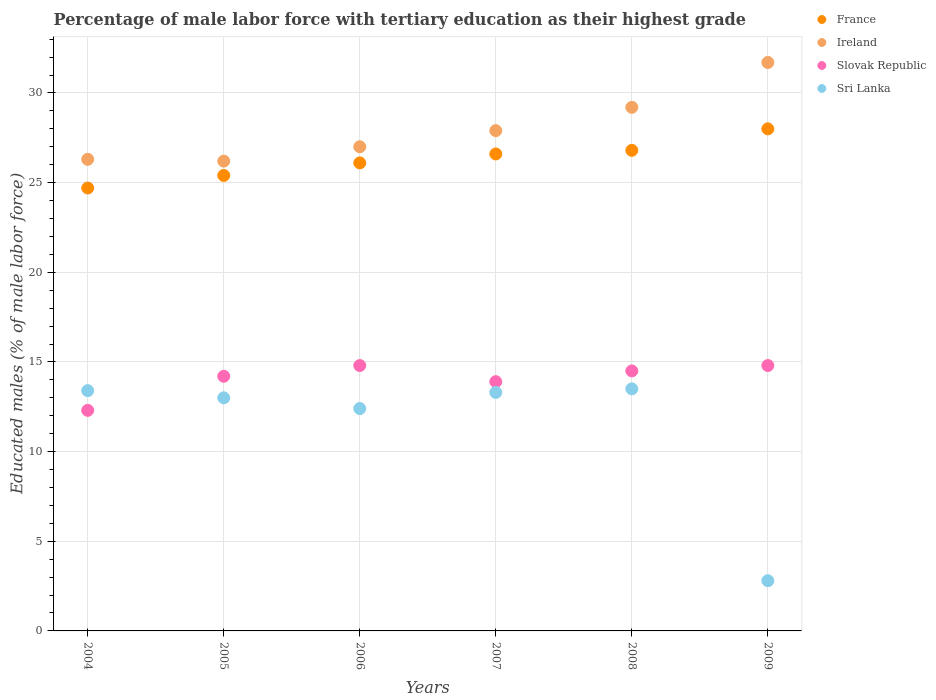What is the percentage of male labor force with tertiary education in Ireland in 2009?
Provide a short and direct response. 31.7. Across all years, what is the maximum percentage of male labor force with tertiary education in Sri Lanka?
Ensure brevity in your answer.  13.5. Across all years, what is the minimum percentage of male labor force with tertiary education in Slovak Republic?
Offer a terse response. 12.3. What is the total percentage of male labor force with tertiary education in France in the graph?
Ensure brevity in your answer.  157.6. What is the difference between the percentage of male labor force with tertiary education in Sri Lanka in 2005 and that in 2009?
Keep it short and to the point. 10.2. What is the difference between the percentage of male labor force with tertiary education in Ireland in 2009 and the percentage of male labor force with tertiary education in Slovak Republic in 2008?
Make the answer very short. 17.2. What is the average percentage of male labor force with tertiary education in Ireland per year?
Keep it short and to the point. 28.05. In the year 2009, what is the difference between the percentage of male labor force with tertiary education in France and percentage of male labor force with tertiary education in Ireland?
Your answer should be compact. -3.7. In how many years, is the percentage of male labor force with tertiary education in France greater than 32 %?
Provide a succinct answer. 0. What is the ratio of the percentage of male labor force with tertiary education in Sri Lanka in 2007 to that in 2009?
Your answer should be compact. 4.75. Is the percentage of male labor force with tertiary education in France in 2006 less than that in 2008?
Provide a short and direct response. Yes. Is the difference between the percentage of male labor force with tertiary education in France in 2006 and 2009 greater than the difference between the percentage of male labor force with tertiary education in Ireland in 2006 and 2009?
Your answer should be very brief. Yes. What is the difference between the highest and the second highest percentage of male labor force with tertiary education in Sri Lanka?
Your answer should be compact. 0.1. What is the difference between the highest and the lowest percentage of male labor force with tertiary education in France?
Make the answer very short. 3.3. Is the sum of the percentage of male labor force with tertiary education in Sri Lanka in 2004 and 2009 greater than the maximum percentage of male labor force with tertiary education in France across all years?
Your answer should be compact. No. Is it the case that in every year, the sum of the percentage of male labor force with tertiary education in Slovak Republic and percentage of male labor force with tertiary education in Sri Lanka  is greater than the sum of percentage of male labor force with tertiary education in Ireland and percentage of male labor force with tertiary education in France?
Your answer should be very brief. No. Is it the case that in every year, the sum of the percentage of male labor force with tertiary education in Ireland and percentage of male labor force with tertiary education in Sri Lanka  is greater than the percentage of male labor force with tertiary education in France?
Your answer should be very brief. Yes. Does the percentage of male labor force with tertiary education in Slovak Republic monotonically increase over the years?
Give a very brief answer. No. Is the percentage of male labor force with tertiary education in Sri Lanka strictly less than the percentage of male labor force with tertiary education in Ireland over the years?
Provide a succinct answer. Yes. How many dotlines are there?
Provide a succinct answer. 4. How many years are there in the graph?
Keep it short and to the point. 6. What is the difference between two consecutive major ticks on the Y-axis?
Ensure brevity in your answer.  5. Are the values on the major ticks of Y-axis written in scientific E-notation?
Your answer should be very brief. No. Does the graph contain any zero values?
Your response must be concise. No. What is the title of the graph?
Offer a very short reply. Percentage of male labor force with tertiary education as their highest grade. Does "Macedonia" appear as one of the legend labels in the graph?
Give a very brief answer. No. What is the label or title of the Y-axis?
Keep it short and to the point. Educated males (% of male labor force). What is the Educated males (% of male labor force) of France in 2004?
Make the answer very short. 24.7. What is the Educated males (% of male labor force) in Ireland in 2004?
Keep it short and to the point. 26.3. What is the Educated males (% of male labor force) in Slovak Republic in 2004?
Provide a short and direct response. 12.3. What is the Educated males (% of male labor force) of Sri Lanka in 2004?
Your answer should be compact. 13.4. What is the Educated males (% of male labor force) in France in 2005?
Make the answer very short. 25.4. What is the Educated males (% of male labor force) in Ireland in 2005?
Offer a terse response. 26.2. What is the Educated males (% of male labor force) in Slovak Republic in 2005?
Give a very brief answer. 14.2. What is the Educated males (% of male labor force) of France in 2006?
Ensure brevity in your answer.  26.1. What is the Educated males (% of male labor force) in Slovak Republic in 2006?
Give a very brief answer. 14.8. What is the Educated males (% of male labor force) of Sri Lanka in 2006?
Provide a succinct answer. 12.4. What is the Educated males (% of male labor force) of France in 2007?
Your response must be concise. 26.6. What is the Educated males (% of male labor force) of Ireland in 2007?
Your answer should be very brief. 27.9. What is the Educated males (% of male labor force) of Slovak Republic in 2007?
Provide a succinct answer. 13.9. What is the Educated males (% of male labor force) in Sri Lanka in 2007?
Give a very brief answer. 13.3. What is the Educated males (% of male labor force) in France in 2008?
Provide a short and direct response. 26.8. What is the Educated males (% of male labor force) in Ireland in 2008?
Offer a very short reply. 29.2. What is the Educated males (% of male labor force) in France in 2009?
Your response must be concise. 28. What is the Educated males (% of male labor force) of Ireland in 2009?
Provide a short and direct response. 31.7. What is the Educated males (% of male labor force) in Slovak Republic in 2009?
Offer a very short reply. 14.8. What is the Educated males (% of male labor force) of Sri Lanka in 2009?
Make the answer very short. 2.8. Across all years, what is the maximum Educated males (% of male labor force) of Ireland?
Make the answer very short. 31.7. Across all years, what is the maximum Educated males (% of male labor force) in Slovak Republic?
Offer a terse response. 14.8. Across all years, what is the maximum Educated males (% of male labor force) in Sri Lanka?
Ensure brevity in your answer.  13.5. Across all years, what is the minimum Educated males (% of male labor force) in France?
Your answer should be compact. 24.7. Across all years, what is the minimum Educated males (% of male labor force) in Ireland?
Provide a short and direct response. 26.2. Across all years, what is the minimum Educated males (% of male labor force) of Slovak Republic?
Your answer should be very brief. 12.3. Across all years, what is the minimum Educated males (% of male labor force) of Sri Lanka?
Offer a terse response. 2.8. What is the total Educated males (% of male labor force) in France in the graph?
Provide a short and direct response. 157.6. What is the total Educated males (% of male labor force) of Ireland in the graph?
Your answer should be very brief. 168.3. What is the total Educated males (% of male labor force) in Slovak Republic in the graph?
Offer a terse response. 84.5. What is the total Educated males (% of male labor force) of Sri Lanka in the graph?
Your answer should be compact. 68.4. What is the difference between the Educated males (% of male labor force) of Ireland in 2004 and that in 2005?
Provide a short and direct response. 0.1. What is the difference between the Educated males (% of male labor force) of Sri Lanka in 2004 and that in 2005?
Offer a terse response. 0.4. What is the difference between the Educated males (% of male labor force) in Slovak Republic in 2004 and that in 2006?
Make the answer very short. -2.5. What is the difference between the Educated males (% of male labor force) of Sri Lanka in 2004 and that in 2006?
Provide a short and direct response. 1. What is the difference between the Educated males (% of male labor force) in Slovak Republic in 2004 and that in 2007?
Your response must be concise. -1.6. What is the difference between the Educated males (% of male labor force) of Sri Lanka in 2004 and that in 2007?
Make the answer very short. 0.1. What is the difference between the Educated males (% of male labor force) of Slovak Republic in 2004 and that in 2008?
Offer a very short reply. -2.2. What is the difference between the Educated males (% of male labor force) of Slovak Republic in 2004 and that in 2009?
Offer a very short reply. -2.5. What is the difference between the Educated males (% of male labor force) in Sri Lanka in 2004 and that in 2009?
Your answer should be compact. 10.6. What is the difference between the Educated males (% of male labor force) of Sri Lanka in 2005 and that in 2006?
Make the answer very short. 0.6. What is the difference between the Educated males (% of male labor force) in France in 2005 and that in 2007?
Offer a very short reply. -1.2. What is the difference between the Educated males (% of male labor force) of Ireland in 2005 and that in 2007?
Your answer should be very brief. -1.7. What is the difference between the Educated males (% of male labor force) in Slovak Republic in 2005 and that in 2007?
Give a very brief answer. 0.3. What is the difference between the Educated males (% of male labor force) in Sri Lanka in 2005 and that in 2007?
Make the answer very short. -0.3. What is the difference between the Educated males (% of male labor force) of France in 2005 and that in 2008?
Offer a very short reply. -1.4. What is the difference between the Educated males (% of male labor force) of Slovak Republic in 2005 and that in 2008?
Give a very brief answer. -0.3. What is the difference between the Educated males (% of male labor force) of France in 2005 and that in 2009?
Provide a succinct answer. -2.6. What is the difference between the Educated males (% of male labor force) of Ireland in 2005 and that in 2009?
Your answer should be very brief. -5.5. What is the difference between the Educated males (% of male labor force) in Slovak Republic in 2006 and that in 2007?
Your answer should be compact. 0.9. What is the difference between the Educated males (% of male labor force) of Sri Lanka in 2006 and that in 2007?
Give a very brief answer. -0.9. What is the difference between the Educated males (% of male labor force) in France in 2006 and that in 2008?
Keep it short and to the point. -0.7. What is the difference between the Educated males (% of male labor force) of Ireland in 2006 and that in 2009?
Offer a terse response. -4.7. What is the difference between the Educated males (% of male labor force) in Sri Lanka in 2006 and that in 2009?
Offer a terse response. 9.6. What is the difference between the Educated males (% of male labor force) in Ireland in 2007 and that in 2008?
Give a very brief answer. -1.3. What is the difference between the Educated males (% of male labor force) of Sri Lanka in 2007 and that in 2008?
Provide a succinct answer. -0.2. What is the difference between the Educated males (% of male labor force) in France in 2007 and that in 2009?
Offer a very short reply. -1.4. What is the difference between the Educated males (% of male labor force) of Ireland in 2008 and that in 2009?
Keep it short and to the point. -2.5. What is the difference between the Educated males (% of male labor force) in Slovak Republic in 2008 and that in 2009?
Give a very brief answer. -0.3. What is the difference between the Educated males (% of male labor force) in Sri Lanka in 2008 and that in 2009?
Keep it short and to the point. 10.7. What is the difference between the Educated males (% of male labor force) in France in 2004 and the Educated males (% of male labor force) in Slovak Republic in 2005?
Provide a succinct answer. 10.5. What is the difference between the Educated males (% of male labor force) of France in 2004 and the Educated males (% of male labor force) of Sri Lanka in 2005?
Your response must be concise. 11.7. What is the difference between the Educated males (% of male labor force) of Ireland in 2004 and the Educated males (% of male labor force) of Slovak Republic in 2005?
Provide a succinct answer. 12.1. What is the difference between the Educated males (% of male labor force) of Ireland in 2004 and the Educated males (% of male labor force) of Sri Lanka in 2005?
Provide a succinct answer. 13.3. What is the difference between the Educated males (% of male labor force) in France in 2004 and the Educated males (% of male labor force) in Ireland in 2006?
Your response must be concise. -2.3. What is the difference between the Educated males (% of male labor force) of Ireland in 2004 and the Educated males (% of male labor force) of Slovak Republic in 2006?
Give a very brief answer. 11.5. What is the difference between the Educated males (% of male labor force) in Slovak Republic in 2004 and the Educated males (% of male labor force) in Sri Lanka in 2006?
Provide a succinct answer. -0.1. What is the difference between the Educated males (% of male labor force) in France in 2004 and the Educated males (% of male labor force) in Ireland in 2007?
Offer a terse response. -3.2. What is the difference between the Educated males (% of male labor force) of France in 2004 and the Educated males (% of male labor force) of Slovak Republic in 2007?
Make the answer very short. 10.8. What is the difference between the Educated males (% of male labor force) of Slovak Republic in 2004 and the Educated males (% of male labor force) of Sri Lanka in 2007?
Ensure brevity in your answer.  -1. What is the difference between the Educated males (% of male labor force) of France in 2004 and the Educated males (% of male labor force) of Ireland in 2008?
Give a very brief answer. -4.5. What is the difference between the Educated males (% of male labor force) in France in 2004 and the Educated males (% of male labor force) in Sri Lanka in 2008?
Provide a short and direct response. 11.2. What is the difference between the Educated males (% of male labor force) of Ireland in 2004 and the Educated males (% of male labor force) of Sri Lanka in 2008?
Provide a short and direct response. 12.8. What is the difference between the Educated males (% of male labor force) of Slovak Republic in 2004 and the Educated males (% of male labor force) of Sri Lanka in 2008?
Your response must be concise. -1.2. What is the difference between the Educated males (% of male labor force) of France in 2004 and the Educated males (% of male labor force) of Ireland in 2009?
Your response must be concise. -7. What is the difference between the Educated males (% of male labor force) in France in 2004 and the Educated males (% of male labor force) in Sri Lanka in 2009?
Offer a very short reply. 21.9. What is the difference between the Educated males (% of male labor force) in Slovak Republic in 2004 and the Educated males (% of male labor force) in Sri Lanka in 2009?
Offer a very short reply. 9.5. What is the difference between the Educated males (% of male labor force) of France in 2005 and the Educated males (% of male labor force) of Ireland in 2006?
Offer a terse response. -1.6. What is the difference between the Educated males (% of male labor force) of Ireland in 2005 and the Educated males (% of male labor force) of Sri Lanka in 2006?
Provide a succinct answer. 13.8. What is the difference between the Educated males (% of male labor force) in France in 2005 and the Educated males (% of male labor force) in Slovak Republic in 2007?
Make the answer very short. 11.5. What is the difference between the Educated males (% of male labor force) of France in 2005 and the Educated males (% of male labor force) of Sri Lanka in 2007?
Your answer should be compact. 12.1. What is the difference between the Educated males (% of male labor force) in Ireland in 2005 and the Educated males (% of male labor force) in Sri Lanka in 2007?
Provide a short and direct response. 12.9. What is the difference between the Educated males (% of male labor force) in Slovak Republic in 2005 and the Educated males (% of male labor force) in Sri Lanka in 2007?
Make the answer very short. 0.9. What is the difference between the Educated males (% of male labor force) in France in 2005 and the Educated males (% of male labor force) in Ireland in 2008?
Ensure brevity in your answer.  -3.8. What is the difference between the Educated males (% of male labor force) of Ireland in 2005 and the Educated males (% of male labor force) of Slovak Republic in 2008?
Your answer should be compact. 11.7. What is the difference between the Educated males (% of male labor force) in Ireland in 2005 and the Educated males (% of male labor force) in Sri Lanka in 2008?
Keep it short and to the point. 12.7. What is the difference between the Educated males (% of male labor force) of Slovak Republic in 2005 and the Educated males (% of male labor force) of Sri Lanka in 2008?
Give a very brief answer. 0.7. What is the difference between the Educated males (% of male labor force) in France in 2005 and the Educated males (% of male labor force) in Ireland in 2009?
Your response must be concise. -6.3. What is the difference between the Educated males (% of male labor force) in France in 2005 and the Educated males (% of male labor force) in Slovak Republic in 2009?
Make the answer very short. 10.6. What is the difference between the Educated males (% of male labor force) in France in 2005 and the Educated males (% of male labor force) in Sri Lanka in 2009?
Keep it short and to the point. 22.6. What is the difference between the Educated males (% of male labor force) in Ireland in 2005 and the Educated males (% of male labor force) in Slovak Republic in 2009?
Your response must be concise. 11.4. What is the difference between the Educated males (% of male labor force) of Ireland in 2005 and the Educated males (% of male labor force) of Sri Lanka in 2009?
Offer a terse response. 23.4. What is the difference between the Educated males (% of male labor force) of Slovak Republic in 2005 and the Educated males (% of male labor force) of Sri Lanka in 2009?
Offer a very short reply. 11.4. What is the difference between the Educated males (% of male labor force) of France in 2006 and the Educated males (% of male labor force) of Slovak Republic in 2007?
Make the answer very short. 12.2. What is the difference between the Educated males (% of male labor force) of Ireland in 2006 and the Educated males (% of male labor force) of Sri Lanka in 2007?
Your answer should be very brief. 13.7. What is the difference between the Educated males (% of male labor force) in Slovak Republic in 2006 and the Educated males (% of male labor force) in Sri Lanka in 2007?
Offer a terse response. 1.5. What is the difference between the Educated males (% of male labor force) in France in 2006 and the Educated males (% of male labor force) in Slovak Republic in 2008?
Keep it short and to the point. 11.6. What is the difference between the Educated males (% of male labor force) in France in 2006 and the Educated males (% of male labor force) in Sri Lanka in 2008?
Offer a very short reply. 12.6. What is the difference between the Educated males (% of male labor force) of Ireland in 2006 and the Educated males (% of male labor force) of Sri Lanka in 2008?
Keep it short and to the point. 13.5. What is the difference between the Educated males (% of male labor force) in Slovak Republic in 2006 and the Educated males (% of male labor force) in Sri Lanka in 2008?
Offer a very short reply. 1.3. What is the difference between the Educated males (% of male labor force) in France in 2006 and the Educated males (% of male labor force) in Slovak Republic in 2009?
Your answer should be compact. 11.3. What is the difference between the Educated males (% of male labor force) of France in 2006 and the Educated males (% of male labor force) of Sri Lanka in 2009?
Your answer should be compact. 23.3. What is the difference between the Educated males (% of male labor force) of Ireland in 2006 and the Educated males (% of male labor force) of Sri Lanka in 2009?
Your answer should be compact. 24.2. What is the difference between the Educated males (% of male labor force) of France in 2007 and the Educated males (% of male labor force) of Ireland in 2008?
Offer a terse response. -2.6. What is the difference between the Educated males (% of male labor force) in France in 2007 and the Educated males (% of male labor force) in Slovak Republic in 2008?
Provide a short and direct response. 12.1. What is the difference between the Educated males (% of male labor force) in France in 2007 and the Educated males (% of male labor force) in Sri Lanka in 2008?
Provide a short and direct response. 13.1. What is the difference between the Educated males (% of male labor force) in France in 2007 and the Educated males (% of male labor force) in Ireland in 2009?
Offer a very short reply. -5.1. What is the difference between the Educated males (% of male labor force) in France in 2007 and the Educated males (% of male labor force) in Sri Lanka in 2009?
Offer a terse response. 23.8. What is the difference between the Educated males (% of male labor force) in Ireland in 2007 and the Educated males (% of male labor force) in Slovak Republic in 2009?
Your answer should be very brief. 13.1. What is the difference between the Educated males (% of male labor force) of Ireland in 2007 and the Educated males (% of male labor force) of Sri Lanka in 2009?
Provide a succinct answer. 25.1. What is the difference between the Educated males (% of male labor force) of Slovak Republic in 2007 and the Educated males (% of male labor force) of Sri Lanka in 2009?
Give a very brief answer. 11.1. What is the difference between the Educated males (% of male labor force) of Ireland in 2008 and the Educated males (% of male labor force) of Slovak Republic in 2009?
Your answer should be very brief. 14.4. What is the difference between the Educated males (% of male labor force) in Ireland in 2008 and the Educated males (% of male labor force) in Sri Lanka in 2009?
Provide a short and direct response. 26.4. What is the average Educated males (% of male labor force) of France per year?
Make the answer very short. 26.27. What is the average Educated males (% of male labor force) of Ireland per year?
Offer a terse response. 28.05. What is the average Educated males (% of male labor force) in Slovak Republic per year?
Your response must be concise. 14.08. What is the average Educated males (% of male labor force) of Sri Lanka per year?
Offer a terse response. 11.4. In the year 2004, what is the difference between the Educated males (% of male labor force) of France and Educated males (% of male labor force) of Slovak Republic?
Ensure brevity in your answer.  12.4. In the year 2004, what is the difference between the Educated males (% of male labor force) in Ireland and Educated males (% of male labor force) in Slovak Republic?
Your answer should be very brief. 14. In the year 2004, what is the difference between the Educated males (% of male labor force) in Slovak Republic and Educated males (% of male labor force) in Sri Lanka?
Make the answer very short. -1.1. In the year 2005, what is the difference between the Educated males (% of male labor force) in France and Educated males (% of male labor force) in Ireland?
Provide a succinct answer. -0.8. In the year 2005, what is the difference between the Educated males (% of male labor force) of Slovak Republic and Educated males (% of male labor force) of Sri Lanka?
Offer a very short reply. 1.2. In the year 2006, what is the difference between the Educated males (% of male labor force) of France and Educated males (% of male labor force) of Ireland?
Your answer should be compact. -0.9. In the year 2007, what is the difference between the Educated males (% of male labor force) of France and Educated males (% of male labor force) of Slovak Republic?
Keep it short and to the point. 12.7. In the year 2007, what is the difference between the Educated males (% of male labor force) in Ireland and Educated males (% of male labor force) in Slovak Republic?
Provide a short and direct response. 14. In the year 2007, what is the difference between the Educated males (% of male labor force) of Slovak Republic and Educated males (% of male labor force) of Sri Lanka?
Your answer should be compact. 0.6. In the year 2008, what is the difference between the Educated males (% of male labor force) in France and Educated males (% of male labor force) in Ireland?
Your response must be concise. -2.4. In the year 2008, what is the difference between the Educated males (% of male labor force) of France and Educated males (% of male labor force) of Slovak Republic?
Ensure brevity in your answer.  12.3. In the year 2008, what is the difference between the Educated males (% of male labor force) in France and Educated males (% of male labor force) in Sri Lanka?
Ensure brevity in your answer.  13.3. In the year 2008, what is the difference between the Educated males (% of male labor force) of Ireland and Educated males (% of male labor force) of Slovak Republic?
Your answer should be compact. 14.7. In the year 2008, what is the difference between the Educated males (% of male labor force) of Slovak Republic and Educated males (% of male labor force) of Sri Lanka?
Your answer should be very brief. 1. In the year 2009, what is the difference between the Educated males (% of male labor force) in France and Educated males (% of male labor force) in Sri Lanka?
Keep it short and to the point. 25.2. In the year 2009, what is the difference between the Educated males (% of male labor force) in Ireland and Educated males (% of male labor force) in Slovak Republic?
Your response must be concise. 16.9. In the year 2009, what is the difference between the Educated males (% of male labor force) of Ireland and Educated males (% of male labor force) of Sri Lanka?
Provide a short and direct response. 28.9. In the year 2009, what is the difference between the Educated males (% of male labor force) of Slovak Republic and Educated males (% of male labor force) of Sri Lanka?
Ensure brevity in your answer.  12. What is the ratio of the Educated males (% of male labor force) of France in 2004 to that in 2005?
Keep it short and to the point. 0.97. What is the ratio of the Educated males (% of male labor force) in Slovak Republic in 2004 to that in 2005?
Your answer should be compact. 0.87. What is the ratio of the Educated males (% of male labor force) of Sri Lanka in 2004 to that in 2005?
Your answer should be compact. 1.03. What is the ratio of the Educated males (% of male labor force) of France in 2004 to that in 2006?
Give a very brief answer. 0.95. What is the ratio of the Educated males (% of male labor force) of Ireland in 2004 to that in 2006?
Keep it short and to the point. 0.97. What is the ratio of the Educated males (% of male labor force) in Slovak Republic in 2004 to that in 2006?
Your response must be concise. 0.83. What is the ratio of the Educated males (% of male labor force) of Sri Lanka in 2004 to that in 2006?
Offer a very short reply. 1.08. What is the ratio of the Educated males (% of male labor force) in Ireland in 2004 to that in 2007?
Your answer should be compact. 0.94. What is the ratio of the Educated males (% of male labor force) in Slovak Republic in 2004 to that in 2007?
Provide a short and direct response. 0.88. What is the ratio of the Educated males (% of male labor force) of Sri Lanka in 2004 to that in 2007?
Offer a terse response. 1.01. What is the ratio of the Educated males (% of male labor force) in France in 2004 to that in 2008?
Ensure brevity in your answer.  0.92. What is the ratio of the Educated males (% of male labor force) in Ireland in 2004 to that in 2008?
Ensure brevity in your answer.  0.9. What is the ratio of the Educated males (% of male labor force) in Slovak Republic in 2004 to that in 2008?
Your answer should be compact. 0.85. What is the ratio of the Educated males (% of male labor force) of Sri Lanka in 2004 to that in 2008?
Your answer should be very brief. 0.99. What is the ratio of the Educated males (% of male labor force) in France in 2004 to that in 2009?
Make the answer very short. 0.88. What is the ratio of the Educated males (% of male labor force) of Ireland in 2004 to that in 2009?
Your answer should be compact. 0.83. What is the ratio of the Educated males (% of male labor force) of Slovak Republic in 2004 to that in 2009?
Offer a very short reply. 0.83. What is the ratio of the Educated males (% of male labor force) of Sri Lanka in 2004 to that in 2009?
Make the answer very short. 4.79. What is the ratio of the Educated males (% of male labor force) in France in 2005 to that in 2006?
Provide a short and direct response. 0.97. What is the ratio of the Educated males (% of male labor force) in Ireland in 2005 to that in 2006?
Provide a short and direct response. 0.97. What is the ratio of the Educated males (% of male labor force) of Slovak Republic in 2005 to that in 2006?
Give a very brief answer. 0.96. What is the ratio of the Educated males (% of male labor force) of Sri Lanka in 2005 to that in 2006?
Provide a short and direct response. 1.05. What is the ratio of the Educated males (% of male labor force) in France in 2005 to that in 2007?
Offer a terse response. 0.95. What is the ratio of the Educated males (% of male labor force) in Ireland in 2005 to that in 2007?
Provide a succinct answer. 0.94. What is the ratio of the Educated males (% of male labor force) in Slovak Republic in 2005 to that in 2007?
Ensure brevity in your answer.  1.02. What is the ratio of the Educated males (% of male labor force) of Sri Lanka in 2005 to that in 2007?
Keep it short and to the point. 0.98. What is the ratio of the Educated males (% of male labor force) in France in 2005 to that in 2008?
Your response must be concise. 0.95. What is the ratio of the Educated males (% of male labor force) in Ireland in 2005 to that in 2008?
Keep it short and to the point. 0.9. What is the ratio of the Educated males (% of male labor force) in Slovak Republic in 2005 to that in 2008?
Give a very brief answer. 0.98. What is the ratio of the Educated males (% of male labor force) in France in 2005 to that in 2009?
Ensure brevity in your answer.  0.91. What is the ratio of the Educated males (% of male labor force) of Ireland in 2005 to that in 2009?
Your answer should be very brief. 0.83. What is the ratio of the Educated males (% of male labor force) in Slovak Republic in 2005 to that in 2009?
Your response must be concise. 0.96. What is the ratio of the Educated males (% of male labor force) in Sri Lanka in 2005 to that in 2009?
Keep it short and to the point. 4.64. What is the ratio of the Educated males (% of male labor force) in France in 2006 to that in 2007?
Offer a terse response. 0.98. What is the ratio of the Educated males (% of male labor force) in Slovak Republic in 2006 to that in 2007?
Your response must be concise. 1.06. What is the ratio of the Educated males (% of male labor force) of Sri Lanka in 2006 to that in 2007?
Offer a terse response. 0.93. What is the ratio of the Educated males (% of male labor force) of France in 2006 to that in 2008?
Your answer should be very brief. 0.97. What is the ratio of the Educated males (% of male labor force) of Ireland in 2006 to that in 2008?
Your answer should be compact. 0.92. What is the ratio of the Educated males (% of male labor force) of Slovak Republic in 2006 to that in 2008?
Your response must be concise. 1.02. What is the ratio of the Educated males (% of male labor force) of Sri Lanka in 2006 to that in 2008?
Give a very brief answer. 0.92. What is the ratio of the Educated males (% of male labor force) in France in 2006 to that in 2009?
Make the answer very short. 0.93. What is the ratio of the Educated males (% of male labor force) in Ireland in 2006 to that in 2009?
Provide a succinct answer. 0.85. What is the ratio of the Educated males (% of male labor force) of Sri Lanka in 2006 to that in 2009?
Give a very brief answer. 4.43. What is the ratio of the Educated males (% of male labor force) of Ireland in 2007 to that in 2008?
Keep it short and to the point. 0.96. What is the ratio of the Educated males (% of male labor force) of Slovak Republic in 2007 to that in 2008?
Offer a terse response. 0.96. What is the ratio of the Educated males (% of male labor force) in Sri Lanka in 2007 to that in 2008?
Provide a succinct answer. 0.99. What is the ratio of the Educated males (% of male labor force) of Ireland in 2007 to that in 2009?
Your answer should be compact. 0.88. What is the ratio of the Educated males (% of male labor force) in Slovak Republic in 2007 to that in 2009?
Your answer should be compact. 0.94. What is the ratio of the Educated males (% of male labor force) in Sri Lanka in 2007 to that in 2009?
Make the answer very short. 4.75. What is the ratio of the Educated males (% of male labor force) of France in 2008 to that in 2009?
Give a very brief answer. 0.96. What is the ratio of the Educated males (% of male labor force) in Ireland in 2008 to that in 2009?
Your answer should be very brief. 0.92. What is the ratio of the Educated males (% of male labor force) in Slovak Republic in 2008 to that in 2009?
Your answer should be compact. 0.98. What is the ratio of the Educated males (% of male labor force) of Sri Lanka in 2008 to that in 2009?
Provide a short and direct response. 4.82. What is the difference between the highest and the second highest Educated males (% of male labor force) in France?
Your response must be concise. 1.2. What is the difference between the highest and the second highest Educated males (% of male labor force) of Sri Lanka?
Your answer should be compact. 0.1. What is the difference between the highest and the lowest Educated males (% of male labor force) in Ireland?
Offer a very short reply. 5.5. What is the difference between the highest and the lowest Educated males (% of male labor force) in Slovak Republic?
Give a very brief answer. 2.5. What is the difference between the highest and the lowest Educated males (% of male labor force) of Sri Lanka?
Offer a very short reply. 10.7. 